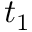<formula> <loc_0><loc_0><loc_500><loc_500>t _ { 1 }</formula> 